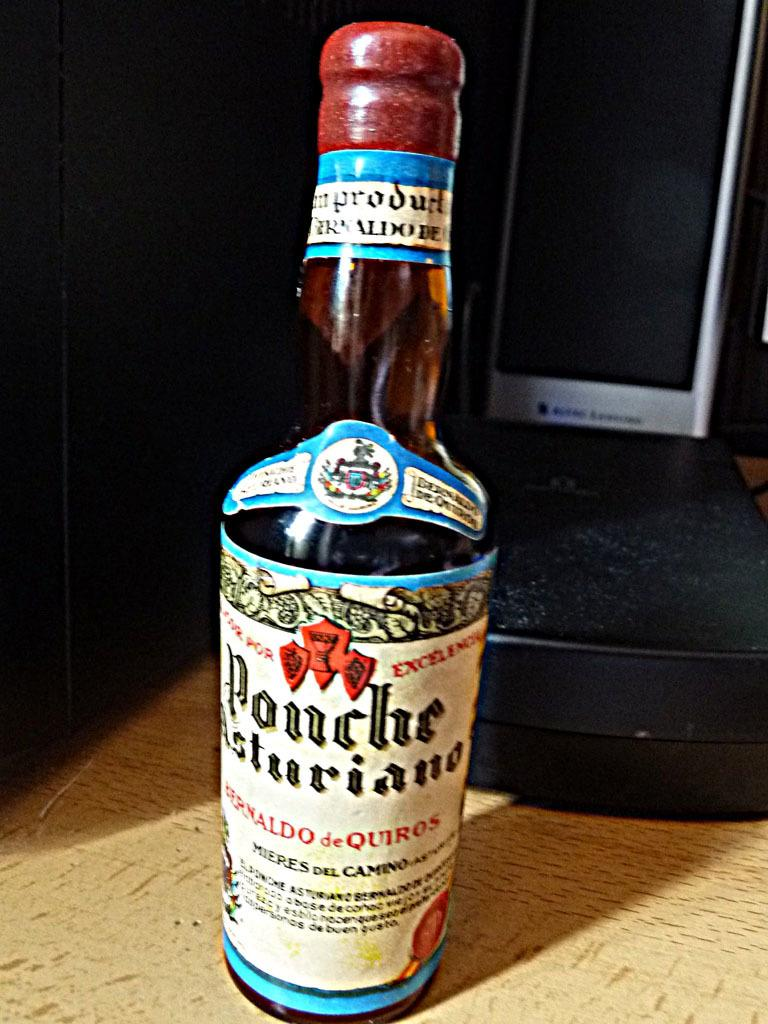<image>
Create a compact narrative representing the image presented. a tall bottle of ponche asturiano with a white label on it 